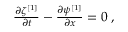Convert formula to latex. <formula><loc_0><loc_0><loc_500><loc_500>\begin{array} { r } { \frac { \partial \zeta ^ { [ 1 ] } } { \partial t } - \frac { \partial \psi ^ { [ 1 ] } } { \partial x } = 0 \, , } \end{array}</formula> 